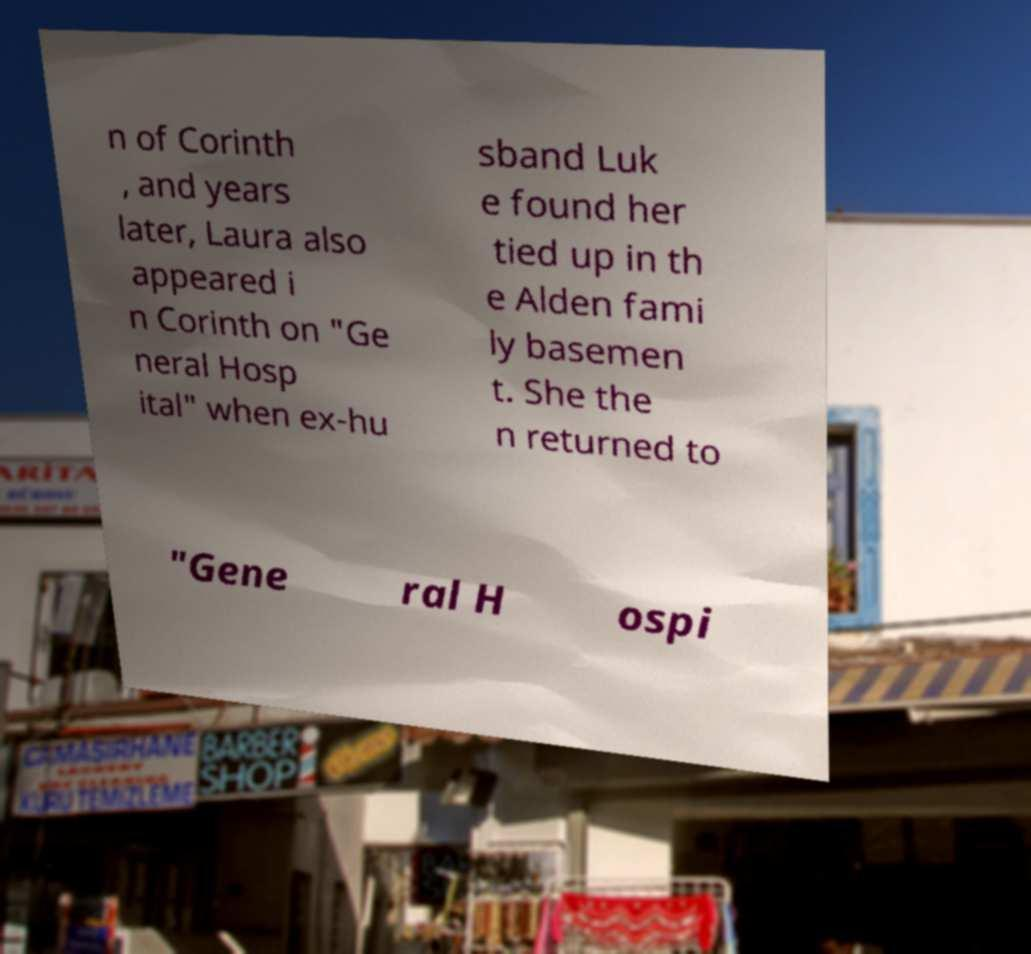Please read and relay the text visible in this image. What does it say? n of Corinth , and years later, Laura also appeared i n Corinth on "Ge neral Hosp ital" when ex-hu sband Luk e found her tied up in th e Alden fami ly basemen t. She the n returned to "Gene ral H ospi 